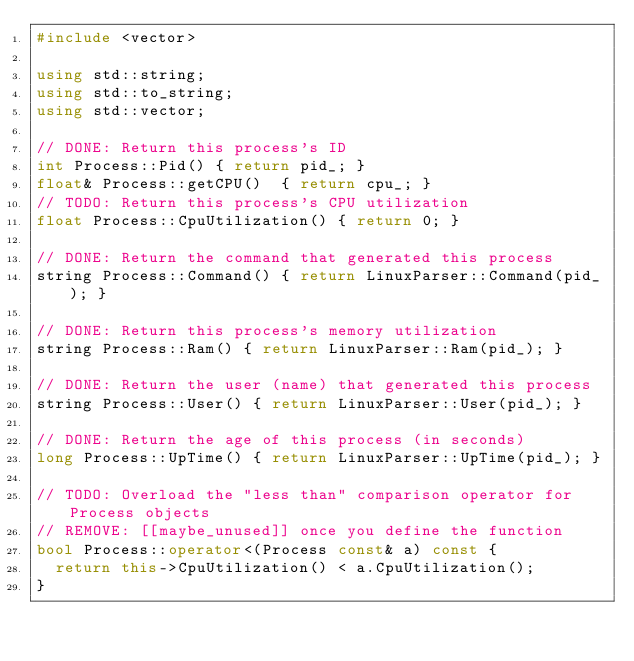Convert code to text. <code><loc_0><loc_0><loc_500><loc_500><_C++_>#include <vector>

using std::string;
using std::to_string;
using std::vector;

// DONE: Return this process's ID
int Process::Pid() { return pid_; }
float& Process::getCPU()  { return cpu_; }
// TODO: Return this process's CPU utilization
float Process::CpuUtilization() { return 0; }

// DONE: Return the command that generated this process
string Process::Command() { return LinuxParser::Command(pid_); }

// DONE: Return this process's memory utilization
string Process::Ram() { return LinuxParser::Ram(pid_); }

// DONE: Return the user (name) that generated this process
string Process::User() { return LinuxParser::User(pid_); }

// DONE: Return the age of this process (in seconds)
long Process::UpTime() { return LinuxParser::UpTime(pid_); }

// TODO: Overload the "less than" comparison operator for Process objects
// REMOVE: [[maybe_unused]] once you define the function
bool Process::operator<(Process const& a) const {
  return this->CpuUtilization() < a.CpuUtilization();
}</code> 